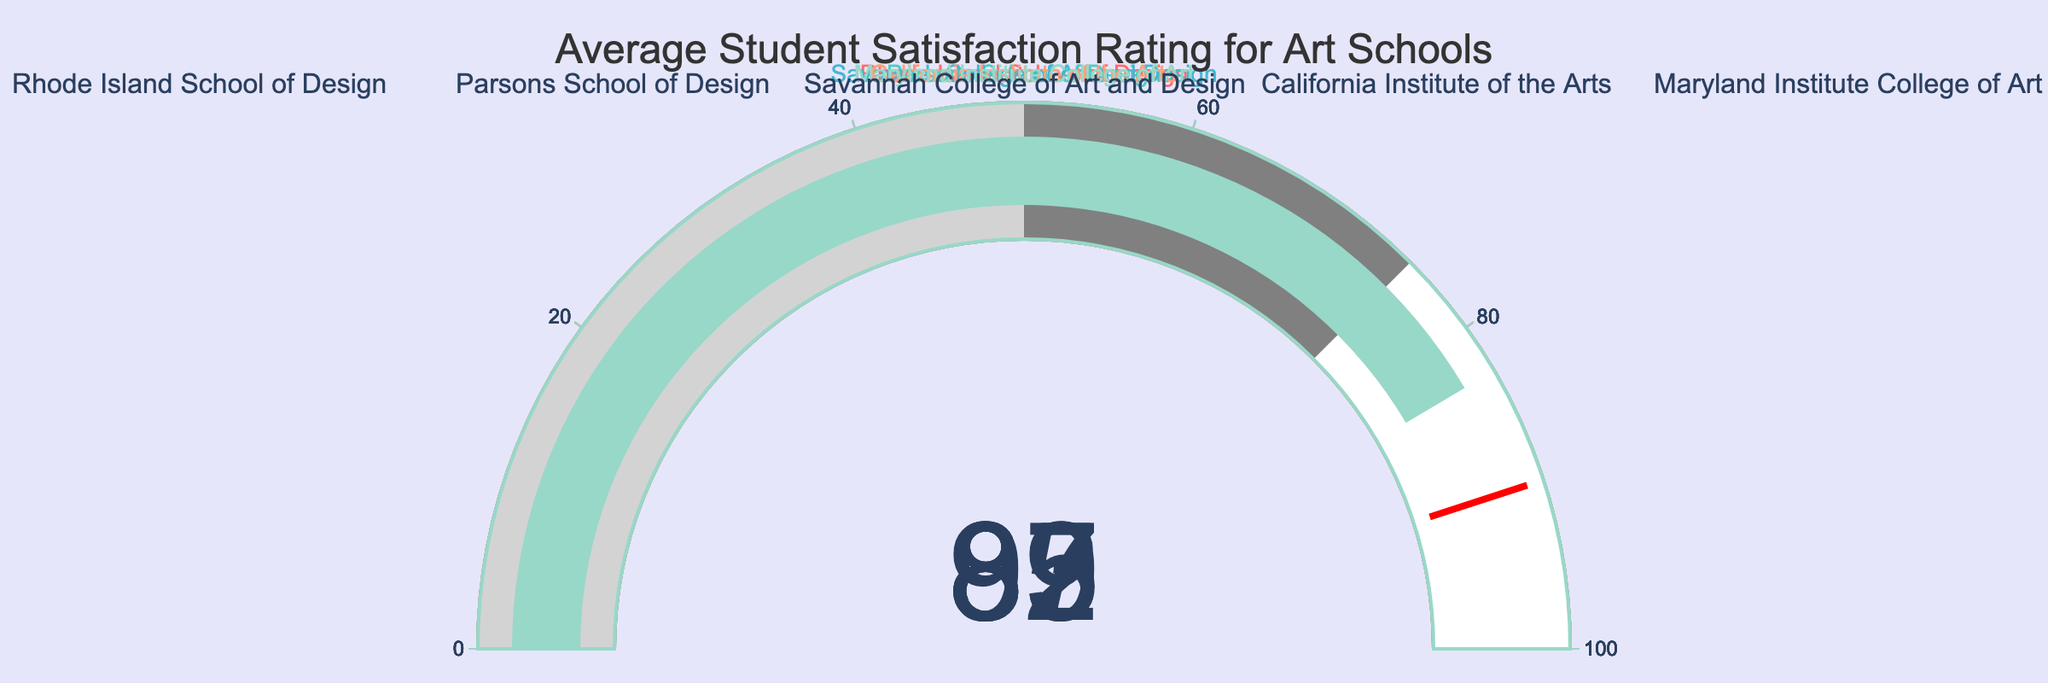What is the title of the figure? The title is usually placed at the top of the figure and is written in larger font size for emphasis. Here, it says "Average Student Satisfaction Rating for Art Schools".
Answer: "Average Student Satisfaction Rating for Art Schools" How many art schools are displayed in the figure? Each gauge chart represents one art school and there are five gauge charts in total.
Answer: 5 Which art school has the highest student satisfaction rating? Look at the gauge charts to find the one with the highest value. Rhode Island School of Design has a satisfaction rating of 92, which is the highest.
Answer: Rhode Island School of Design What are the student satisfaction ratings for California Institute of the Arts and Savannah College of Art and Design, and how do they compare? The satisfaction rating for California Institute of the Arts is 85 and for Savannah College of Art and Design is 87. By comparing the two values, Savannah College of Art and Design has a higher rating by 2 points.
Answer: California Institute of the Arts: 85, Savannah College of Art and Design: 87, Savannah College of Art and Design has a higher rating by 2 points What is the average satisfaction rating for all the art schools combined? Add all the satisfaction ratings (92 + 89 + 87 + 85 + 83) to get 436. Then divide by the number of schools (5) to get the average, which is 436 / 5 = 87.2.
Answer: 87.2 Which art school has a satisfaction rating below the threshold value (90)? Look for the gauge charts that have a rating below 90. The schools with ratings below this threshold are Parsons School of Design, Savannah College of Art and Design, California Institute of the Arts, and Maryland Institute College of Art.
Answer: Parsons School of Design, Savannah College of Art and Design, California Institute of the Arts, Maryland Institute College of Art What's the total sum of satisfaction ratings for Maryland Institute College of Art and Parsons School of Design? Add the ratings for the two schools: 83 (Maryland Institute College of Art) + 89 (Parsons School of Design) = 172.
Answer: 172 How many art schools have their satisfaction rating above 85? Count the gauge charts with satisfaction ratings higher than 85. The schools are Rhode Island School of Design, Parsons School of Design, and Savannah College of Art and Design, making it a total of 3 schools.
Answer: 3 